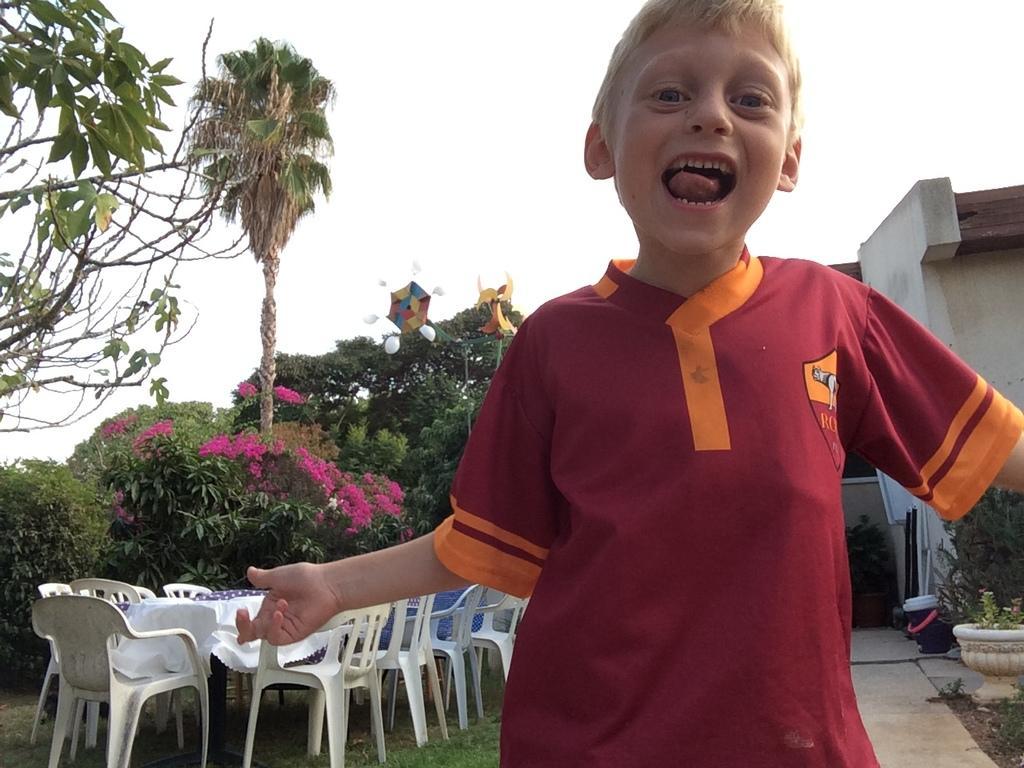Can you describe this image briefly? In this image i can see a boy standing, and in the background i can see few chairs, plants, sky and a building. 